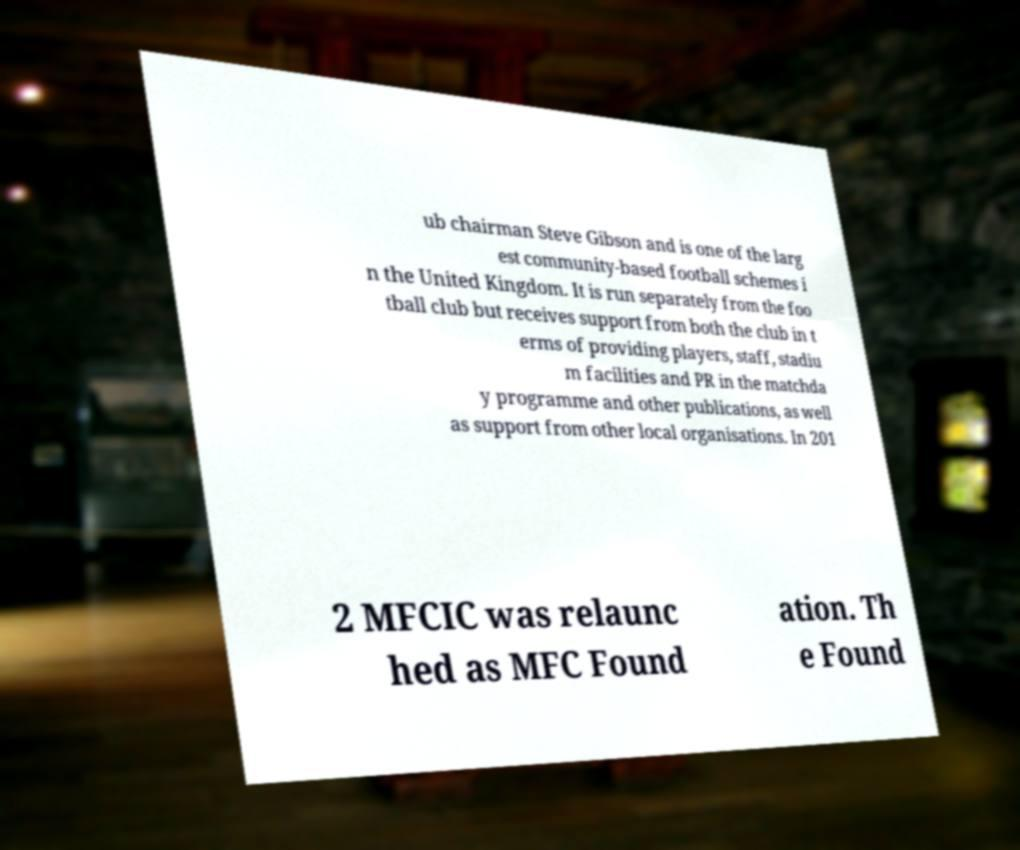Could you assist in decoding the text presented in this image and type it out clearly? ub chairman Steve Gibson and is one of the larg est community-based football schemes i n the United Kingdom. It is run separately from the foo tball club but receives support from both the club in t erms of providing players, staff, stadiu m facilities and PR in the matchda y programme and other publications, as well as support from other local organisations. In 201 2 MFCIC was relaunc hed as MFC Found ation. Th e Found 